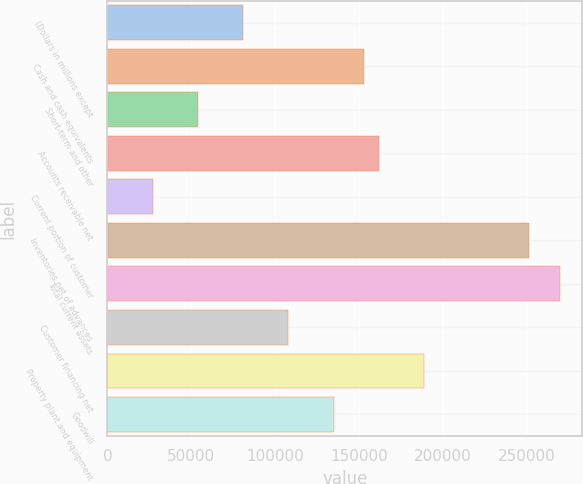Convert chart. <chart><loc_0><loc_0><loc_500><loc_500><bar_chart><fcel>(Dollars in millions except<fcel>Cash and cash equivalents<fcel>Short-term and other<fcel>Accounts receivable net<fcel>Current portion of customer<fcel>Inventories net of advances<fcel>Total current assets<fcel>Customer financing net<fcel>Property plant and equipment<fcel>Goodwill<nl><fcel>81003.3<fcel>152953<fcel>54022.2<fcel>161947<fcel>27041.1<fcel>251884<fcel>269871<fcel>107984<fcel>188928<fcel>134966<nl></chart> 